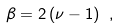<formula> <loc_0><loc_0><loc_500><loc_500>\beta = 2 \, ( \nu - 1 ) \ ,</formula> 